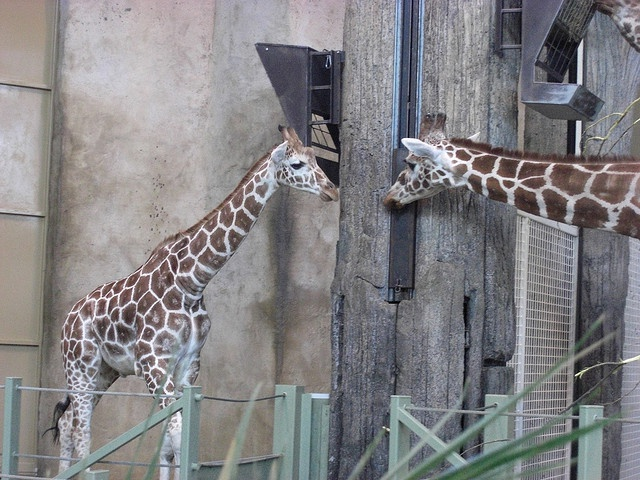Describe the objects in this image and their specific colors. I can see giraffe in gray, darkgray, and lightgray tones and giraffe in gray, darkgray, black, and lightgray tones in this image. 